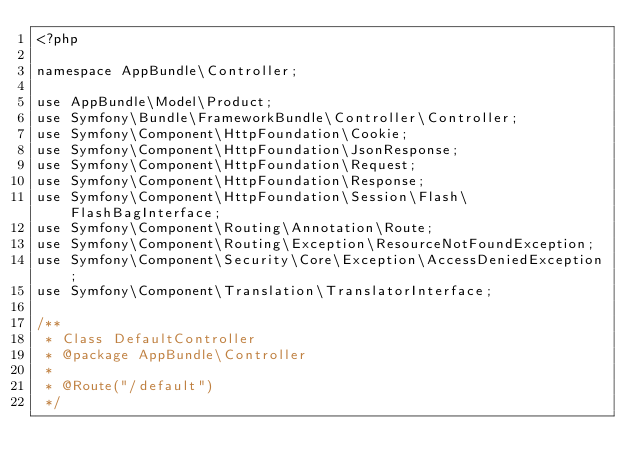Convert code to text. <code><loc_0><loc_0><loc_500><loc_500><_PHP_><?php

namespace AppBundle\Controller;

use AppBundle\Model\Product;
use Symfony\Bundle\FrameworkBundle\Controller\Controller;
use Symfony\Component\HttpFoundation\Cookie;
use Symfony\Component\HttpFoundation\JsonResponse;
use Symfony\Component\HttpFoundation\Request;
use Symfony\Component\HttpFoundation\Response;
use Symfony\Component\HttpFoundation\Session\Flash\FlashBagInterface;
use Symfony\Component\Routing\Annotation\Route;
use Symfony\Component\Routing\Exception\ResourceNotFoundException;
use Symfony\Component\Security\Core\Exception\AccessDeniedException;
use Symfony\Component\Translation\TranslatorInterface;

/**
 * Class DefaultController
 * @package AppBundle\Controller
 *
 * @Route("/default")
 */</code> 